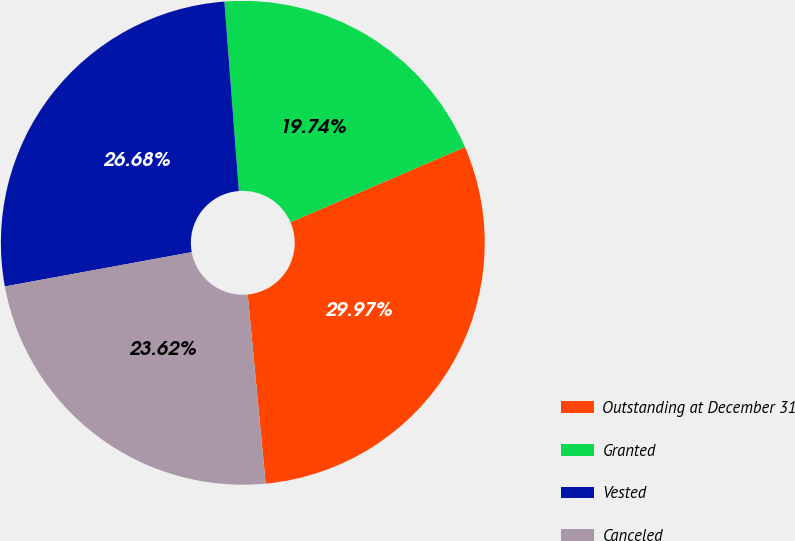Convert chart to OTSL. <chart><loc_0><loc_0><loc_500><loc_500><pie_chart><fcel>Outstanding at December 31<fcel>Granted<fcel>Vested<fcel>Canceled<nl><fcel>29.97%<fcel>19.74%<fcel>26.68%<fcel>23.62%<nl></chart> 